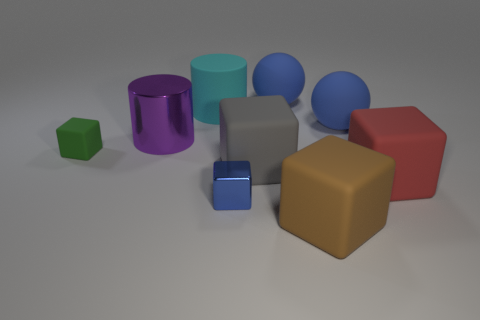The large sphere on the left side of the big rubber thing that is in front of the big red rubber object is what color?
Your answer should be very brief. Blue. Are there fewer large blue spheres that are in front of the red object than small things that are on the right side of the large gray matte cube?
Ensure brevity in your answer.  No. Is the size of the red object the same as the cylinder right of the large shiny thing?
Your response must be concise. Yes. What shape is the blue thing that is both behind the red cube and in front of the cyan matte thing?
Your answer should be compact. Sphere. The green thing that is made of the same material as the large brown thing is what size?
Your answer should be very brief. Small. There is a rubber ball behind the matte cylinder; how many small metallic blocks are in front of it?
Ensure brevity in your answer.  1. Is the large block that is left of the big brown rubber cube made of the same material as the small green object?
Provide a succinct answer. Yes. Is there any other thing that has the same material as the big red thing?
Keep it short and to the point. Yes. There is a thing that is in front of the small cube in front of the tiny green matte block; how big is it?
Your response must be concise. Large. There is a blue matte sphere that is behind the large sphere in front of the sphere left of the brown cube; what is its size?
Make the answer very short. Large. 